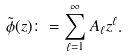<formula> <loc_0><loc_0><loc_500><loc_500>\tilde { \phi } ( z ) \colon = \sum _ { \ell = 1 } ^ { \infty } A _ { \ell } z ^ { \ell } .</formula> 